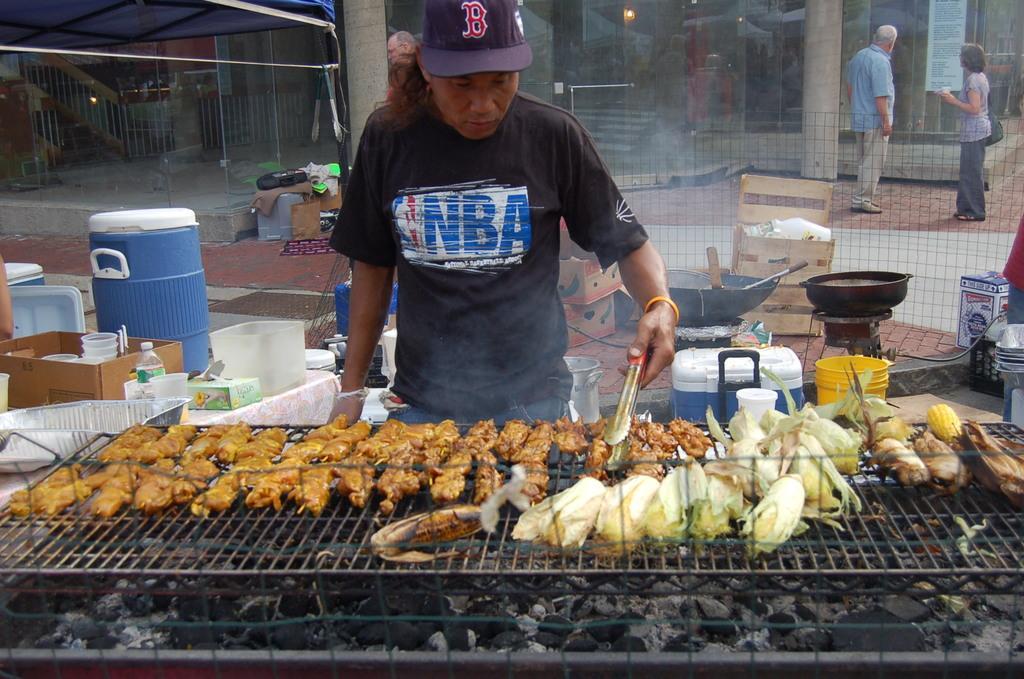In one or two sentences, can you explain what this image depicts? In this image there is a person holding the tongue is frying the meat on the barbecue grill, behind the person there are some objects, behind the objects there is a couple standing and looking at a poster on the glass wall, in the background of the image there are pillars, stairs and there is a building. 